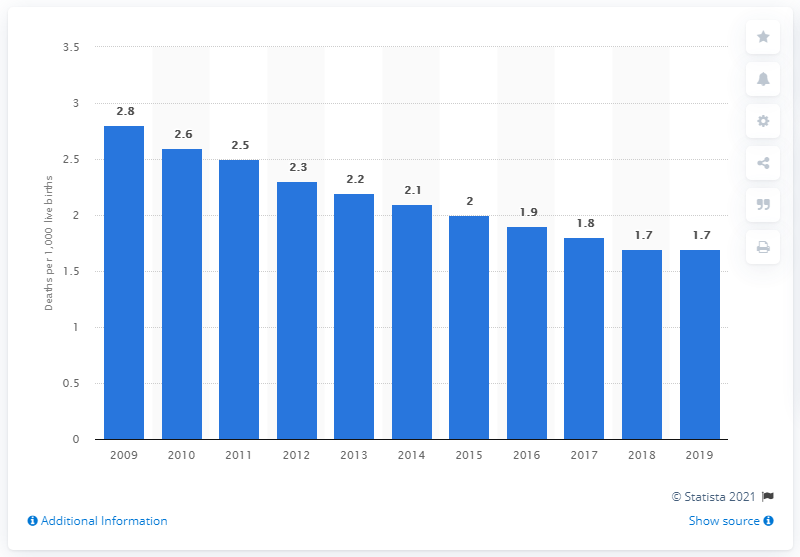Specify some key components in this picture. The infant mortality rate in Slovenia in 2019 was 1.7. 